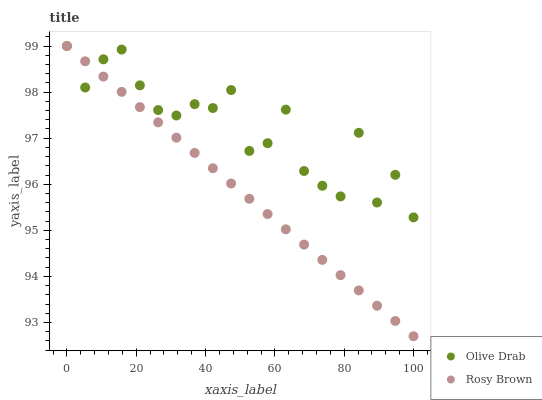Does Rosy Brown have the minimum area under the curve?
Answer yes or no. Yes. Does Olive Drab have the maximum area under the curve?
Answer yes or no. Yes. Does Olive Drab have the minimum area under the curve?
Answer yes or no. No. Is Rosy Brown the smoothest?
Answer yes or no. Yes. Is Olive Drab the roughest?
Answer yes or no. Yes. Is Olive Drab the smoothest?
Answer yes or no. No. Does Rosy Brown have the lowest value?
Answer yes or no. Yes. Does Olive Drab have the lowest value?
Answer yes or no. No. Does Olive Drab have the highest value?
Answer yes or no. Yes. Does Olive Drab intersect Rosy Brown?
Answer yes or no. Yes. Is Olive Drab less than Rosy Brown?
Answer yes or no. No. Is Olive Drab greater than Rosy Brown?
Answer yes or no. No. 